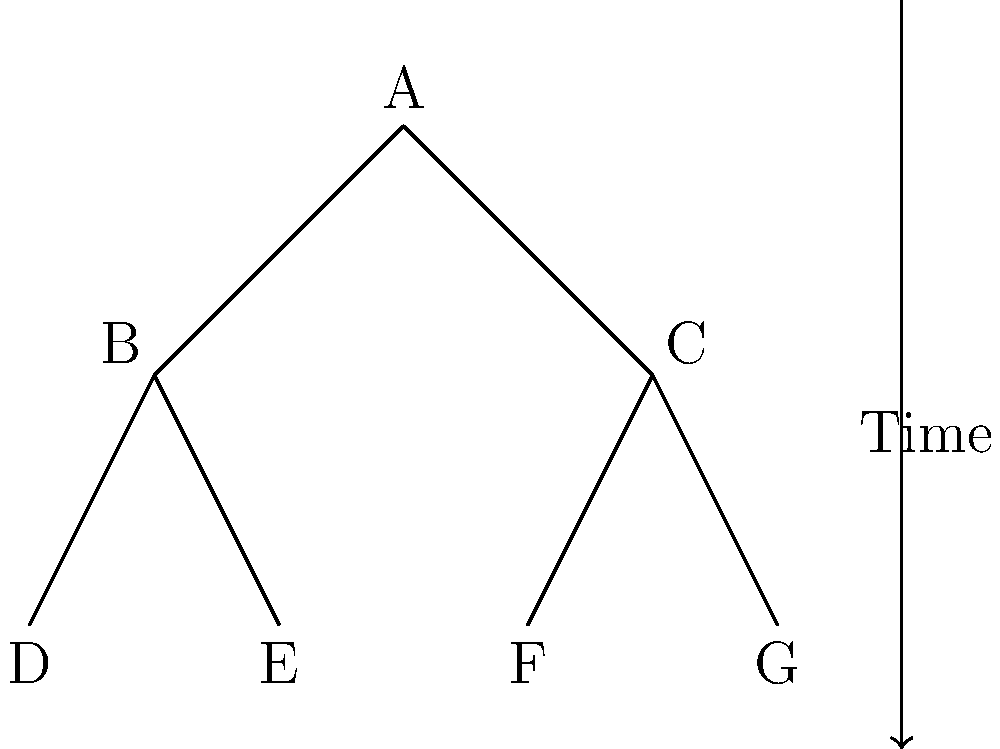In this simplified evolutionary tree diagram, which two species are most closely related? To determine which two species are most closely related in an evolutionary tree diagram, we need to follow these steps:

1. Identify the tips of the tree: In this case, the tips are labeled D, E, F, and G. These represent the extant (living) species.

2. Trace back from the tips to find the most recent common ancestor: 
   - D and E share a common ancestor at B
   - F and G share a common ancestor at C

3. Compare the depth of these common ancestors:
   - The common ancestor of D and E (point B) is one branch point away from the tips
   - The common ancestor of F and G (point C) is also one branch point away from the tips

4. Identify the pair with the most recent common ancestor:
   Both pairs (D and E, F and G) have equally recent common ancestors, as they are both separated by one branch point.

5. In cases of equal depth, we consider both pairs to be equally closely related.

Therefore, there are two pairs of species that are most closely related: D and E, and F and G.
Answer: D and E, F and G 